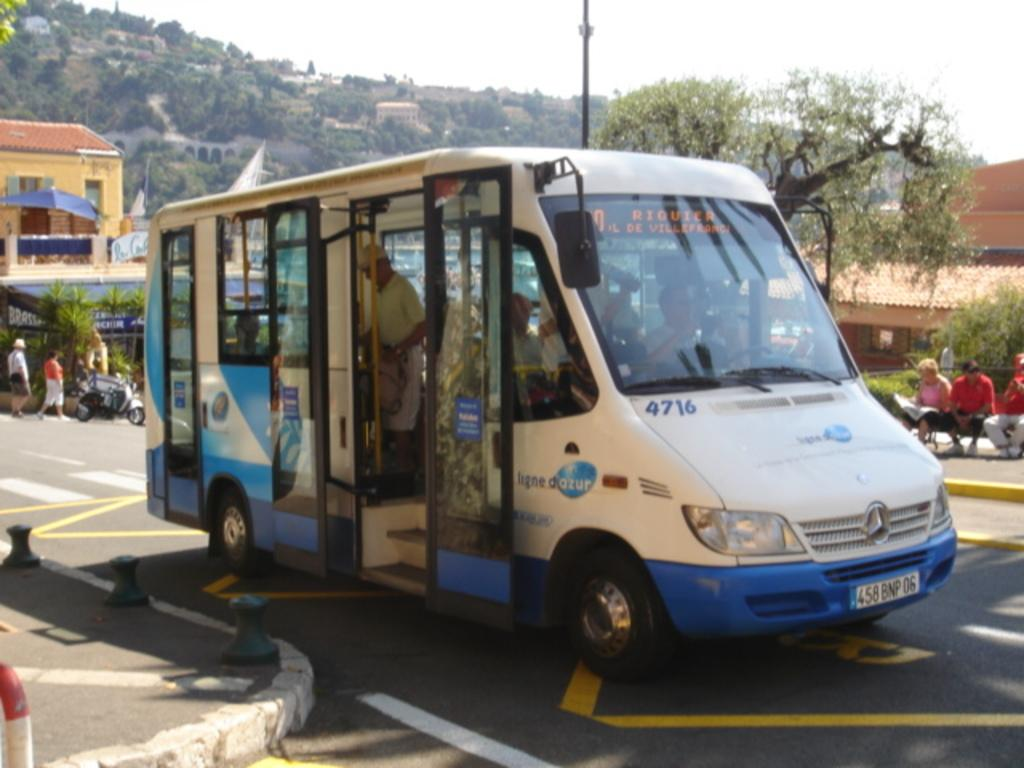What is the main subject of the image? There is a person in a vehicle in the image. What else can be seen around the vehicle? There are people around the vehicle. How many vehicles are visible in the image? There are vehicles visible in the image. What type of natural elements are present in the image? Trees and plants are visible in the image. What type of man-made structures are present in the image? Houses are present in the image. What type of statement can be seen on the person's feet in the image? There is no statement visible on the person's feet in the image. How many rings are visible on the trees in the image? There are no rings visible on the trees in the image; rings are not a feature of trees. 